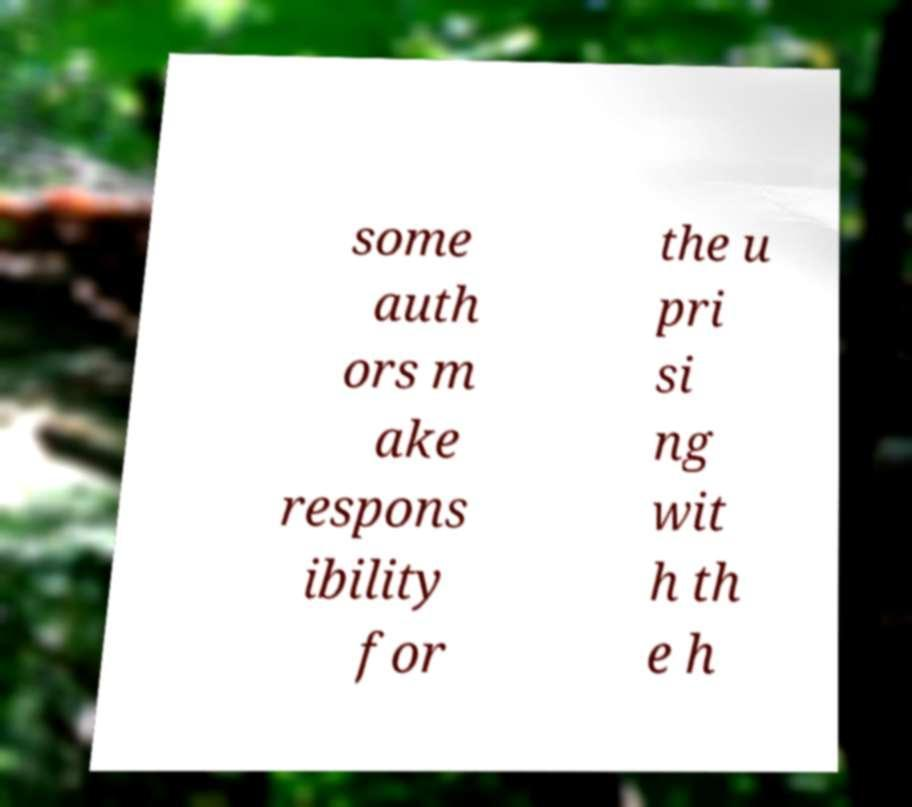I need the written content from this picture converted into text. Can you do that? some auth ors m ake respons ibility for the u pri si ng wit h th e h 